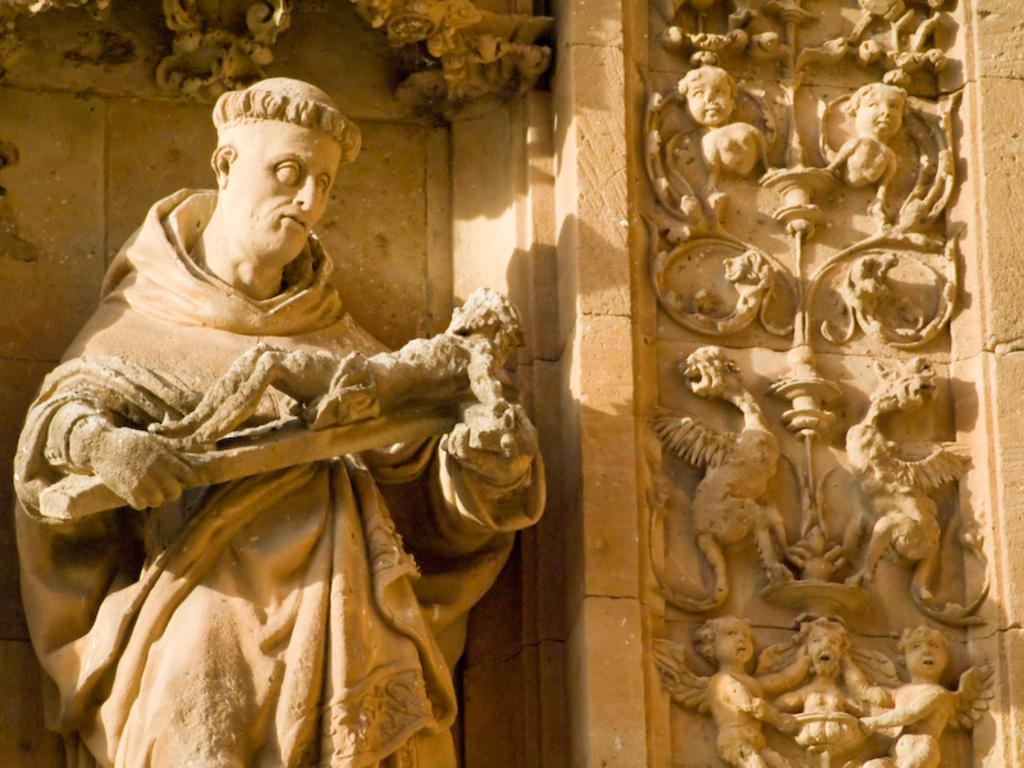What is the main subject of the image? There is a sculpture of a man in the image. What is the man holding in the sculpture? The man is holding an object in the sculpture. What is visible behind the man in the image? There is a wall behind the man in the image. Are there any other sculptures or artwork in the image? Yes, there are sculptures on the wall in the image. What type of operation is being performed on the man in the image? There is no operation being performed on the man in the image; it is a sculpture of a man holding an object. How much money is visible in the image? There is no money visible in the image; it features a sculpture of a man holding an object and other sculptures on a wall. 